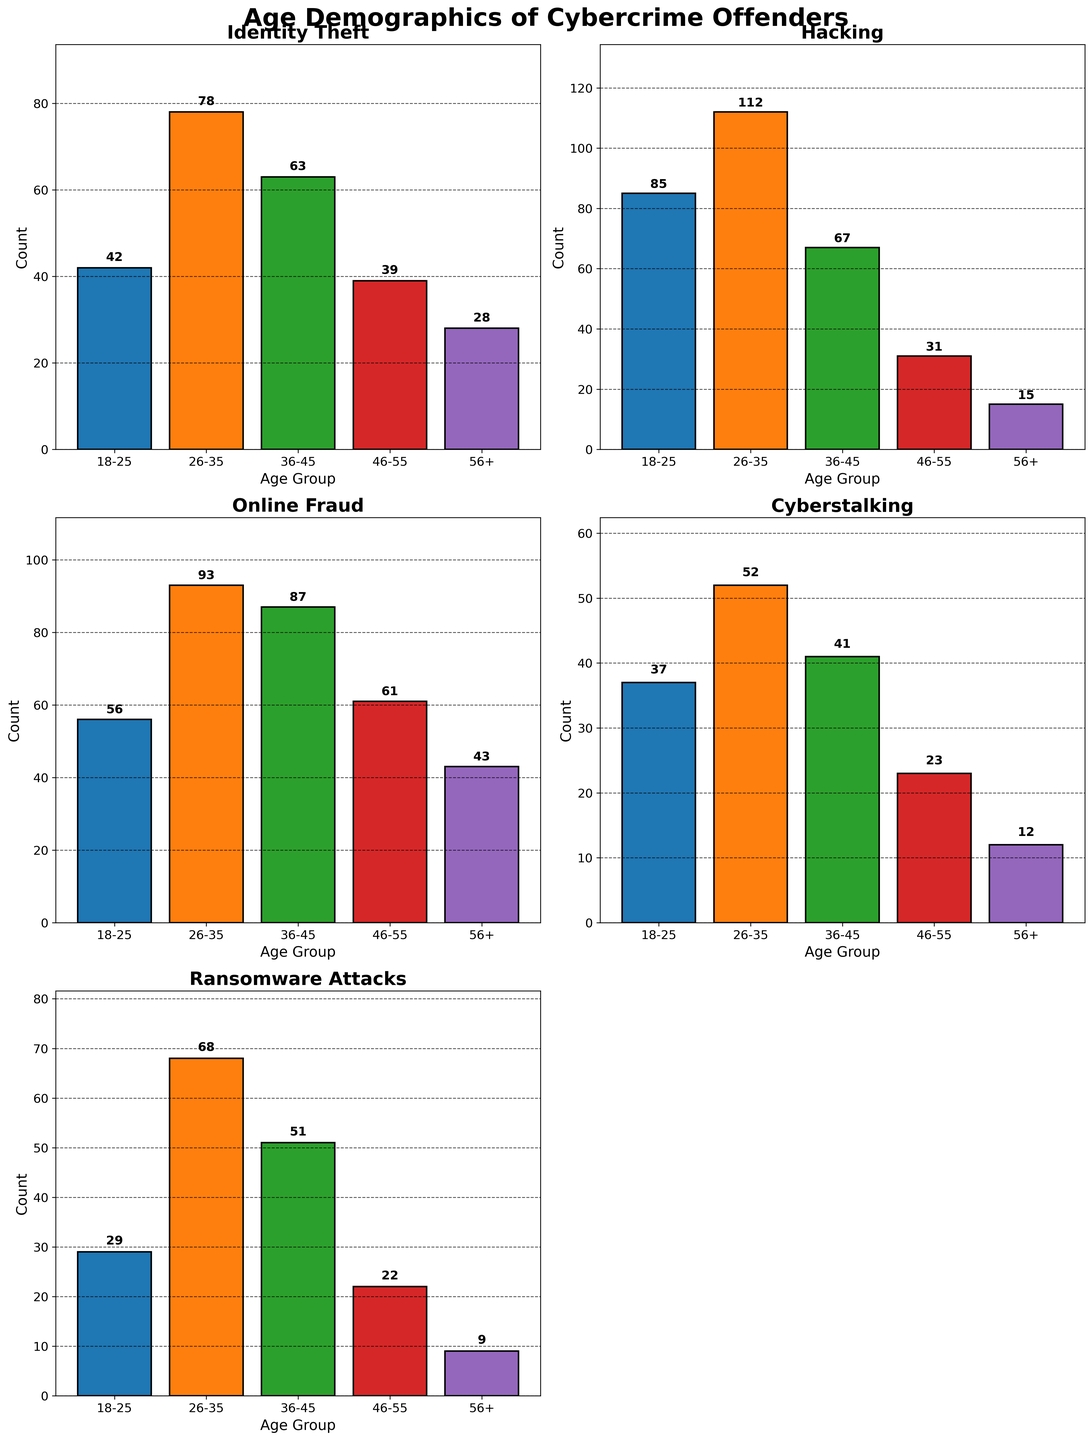What is the title of the figure? The title of the figure is located at the top and it reads "Age Demographics of Cybercrime Offenders".
Answer: Age Demographics of Cybercrime Offenders How many age groups are there in each offense category? Each subplot shows the count of offenders in five distinct age groups labeled as 18-25, 26-35, 36-45, 46-55, and 56+.
Answer: Five Which offense category has the highest number of offenders in the 18-25 age group? We need to look at the count bars for the 18-25 age group across all subplots. Hacking has the tallest bar with 85 offenders.
Answer: Hacking What is the total count of offenders for Identity Theft across all age groups? Sum the counts for all age groups under the Identity Theft category: 42 + 78 + 63 + 39 + 28 = 250.
Answer: 250 Which offense category has the fewest number of offenders in the 56+ age group? We need to compare the bars for the 56+ age group across categories. Cyberstalking has the smallest count with 12 offenders.
Answer: Cyberstalking What is the average count of offenders in the 26-35 age group across all offense categories? Sum the counts for all categories in the 26-35 age group and divide by the number of categories: (78 + 112 + 93 + 52 + 68) / 5 = 403 / 5 = 80.6.
Answer: 80.6 Compare the number of offenders aged 36-45 in Hacking and Online Fraud. Which category has more? Check the counts for 36-45 age group in Hacking (67) and Online Fraud (87). Online Fraud has more offenders.
Answer: Online Fraud Which age group has the highest total number of offenders when aggregated across all offense categories? Sum up the counts for each age group across all categories and compare: 
For 18-25: 42 + 85 + 56 + 37 + 29 = 249
For 26-35: 78 + 112 + 93 + 52 + 68 = 403
For 36-45: 63 + 67 + 87 + 41 + 51 = 309
For 46-55: 39 + 31 + 61 + 23 + 22 = 176
For 56+: 28 + 15 + 43 + 12 + 9 = 107
The 26-35 age group has the highest total with 403 offenders.
Answer: 26-35 What is the combined count of offenders in the 46-55 and 56+ age groups for Cyberstalking? Add the counts for both age groups in Cyberstalking: 23 + 12 = 35.
Answer: 35 What is the maximum count observed in any age group for any offense category? Identify the highest single count value across all subplots and age groups. The highest is in Hacking (26-35) with a count of 112.
Answer: 112 